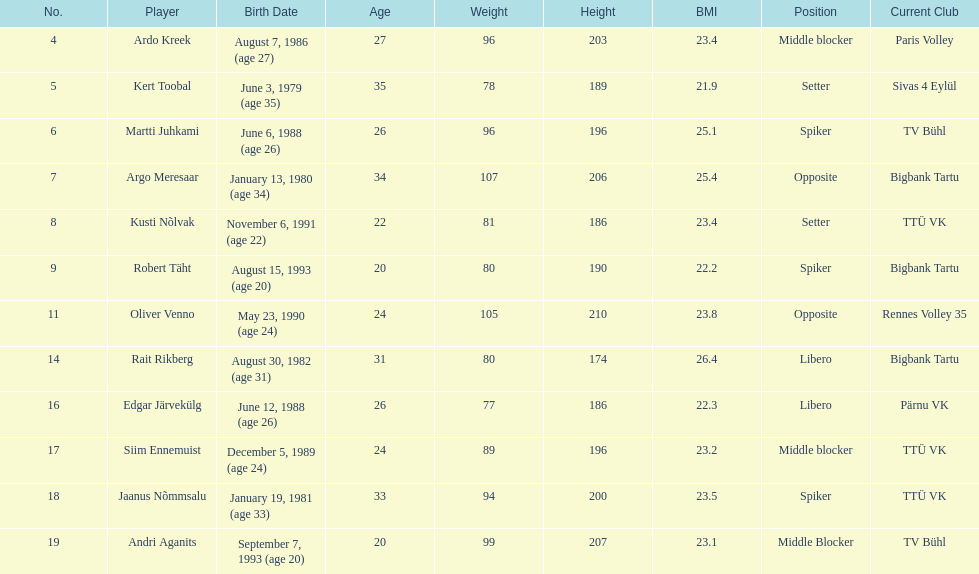How much taller in oliver venno than rait rikberg? 36. 